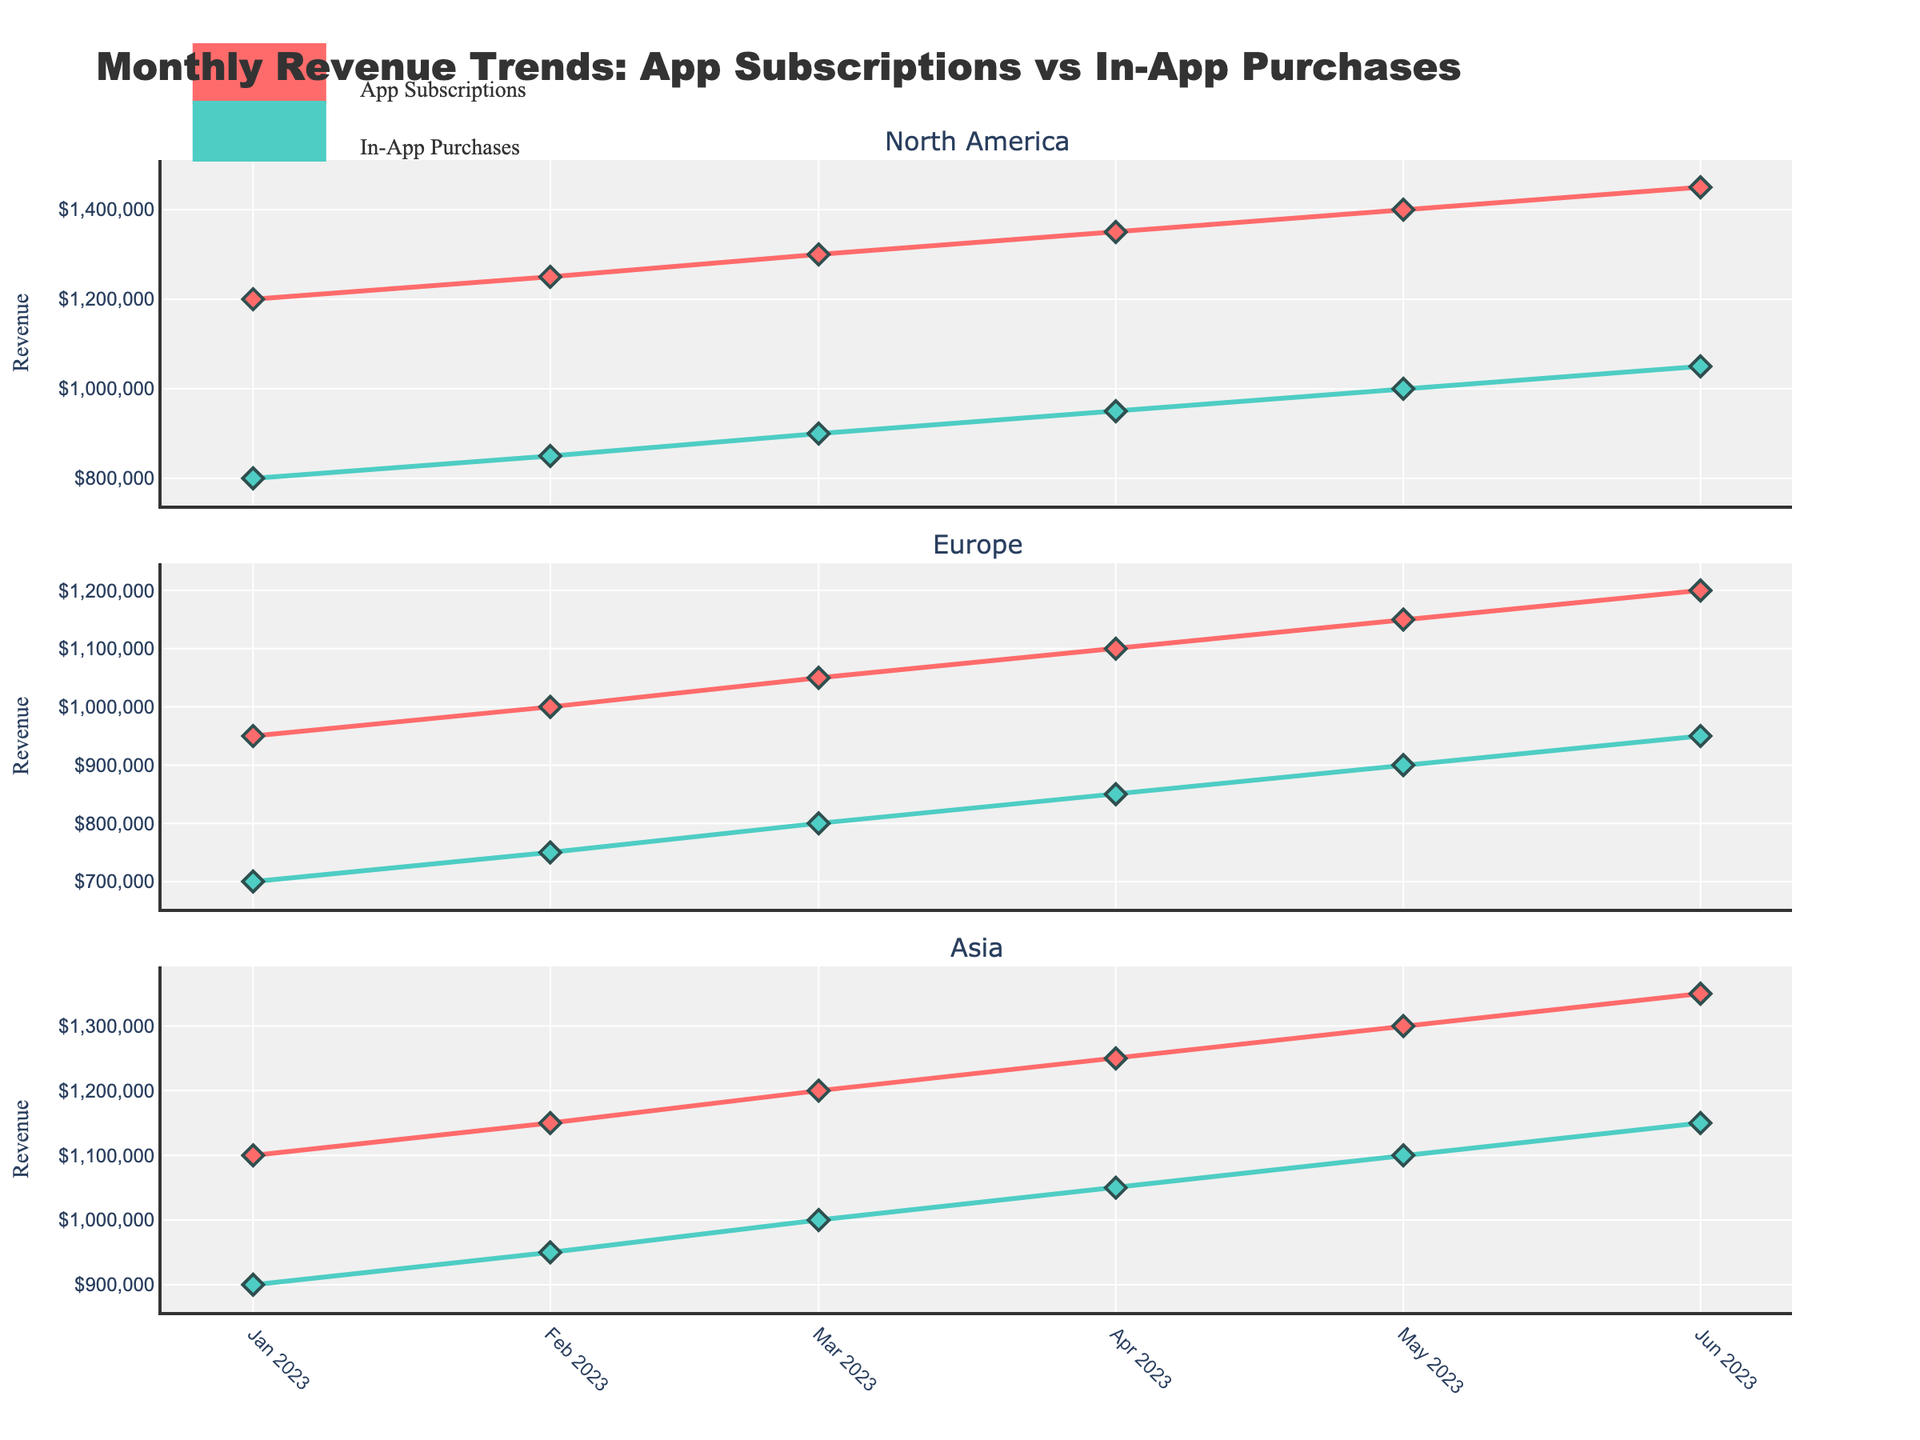What is the highest revenue generated from App Subscriptions in North America for any given month? In the figure, look at the North America subplot and identify the highest peak for the App Subscriptions line, which is marked with red diamonds. The highest point occurs in June where the revenue reaches $1,450,000.
Answer: $1,450,000 How does the revenue trend for App Subscriptions in Europe compare to that in Asia from January to June? Compare the red diamond trend lines in both the Europe and Asia subplots. In Europe, the trend for App Subscriptions shows a steady but less steep rise, starting from $950,000 in January to $1,200,000 in June. In Asia, the trend is also upward but at a similar steady rate, starting from $1,100,000 in January to $1,350,000 by June.
Answer: Both trends are upward, but Asia starts higher and ends higher What is the difference in revenue generated from App Subscriptions and In-App Purchases in Europe in the month of May? Look at the Europe subplot and find both the App Subscriptions and In-App Purchases values for May, which are marked with red diamonds and green circles, respectively. Subscriptions are $1,150,000 and Purchases are $900,000 in May. The difference is $1,150,000 - $900,000 = $250,000.
Answer: $250,000 Which market showed the highest revenue from In-App Purchases in June? Examine the green circle lines across all subplots for June. North America reaches $1,050,000, Europe reaches $950,000, and Asia reaches $1,150,000 in June. Consequently, Asia has the highest In-App Purchases revenue for June.
Answer: Asia Across all three markets, what is the general trend for revenue generated from In-App Purchases from January to June? Examine the green circle trend lines in each subplot from January to June. North America, Europe, and Asia all show a general increasing trend for In-App Purchases revenue, indicating a consistent rise across all markets.
Answer: Increasing trend In which month and market did App Subscriptions first surpass $1,200,000? Look for the first occurrence of red diamonds crossing $1,200,000 in any market subplot. In North America, this happens in April ($1,350,000).
Answer: April, North America Compare the growth of App Subscriptions revenue in North America with that in Europe from January to June. Which market experienced faster growth? Look at the slope of the red diamond trend lines in both subplots. North America starts at $1,200,000 in January and rises to $1,450,000 in June, a $250,000 increase. Europe starts at $950,000 in January and rises to $1,200,000 in June, also showing a $250,000 increase, but the percentage growth is different. North America's growth rate: (~21%), Europe's growth rate: (~26%). Therefore, Europe experienced faster growth.
Answer: Europe What is the combined revenue from App Subscriptions and In-App Purchases in Asia for March? Sum the revenues shown by red diamonds and green circles for March in the Asia subplot. App Subscriptions: $1,200,000, In-App Purchases: $1,000,000. Combined: $1,200,000 + $1,000,000 = $2,200,000.
Answer: $2,200,000 What is the trend difference between App Subscriptions and In-App Purchases in North America from April to May? Observe the North America subplot. For App Subscriptions (red diamonds), the revenue increases from $1,350,000 in April to $1,400,000 in May. For In-App Purchases (green circles), the revenue increases from $950,000 in April to $1,000,000 in May. Both show an increasing trend, but App Subscriptions have a slightly higher increase in revenue.
Answer: Both increasing, Subscriptions have a higher increase Between App Subscriptions and In-App Purchases, which type of revenue showed a greater increase in Asia from February to March? Look at the Asia subplot for February to March. App Subscriptions increase from $1,150,000 to $1,200,000, a $50,000 increase. In-App Purchases increase from $950,000 to $1,000,000, also a $50,000 increase. Both types of revenue show an equal increase.
Answer: Equal increase 